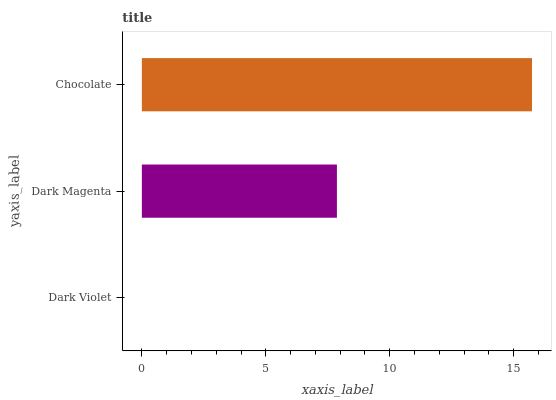Is Dark Violet the minimum?
Answer yes or no. Yes. Is Chocolate the maximum?
Answer yes or no. Yes. Is Dark Magenta the minimum?
Answer yes or no. No. Is Dark Magenta the maximum?
Answer yes or no. No. Is Dark Magenta greater than Dark Violet?
Answer yes or no. Yes. Is Dark Violet less than Dark Magenta?
Answer yes or no. Yes. Is Dark Violet greater than Dark Magenta?
Answer yes or no. No. Is Dark Magenta less than Dark Violet?
Answer yes or no. No. Is Dark Magenta the high median?
Answer yes or no. Yes. Is Dark Magenta the low median?
Answer yes or no. Yes. Is Dark Violet the high median?
Answer yes or no. No. Is Dark Violet the low median?
Answer yes or no. No. 